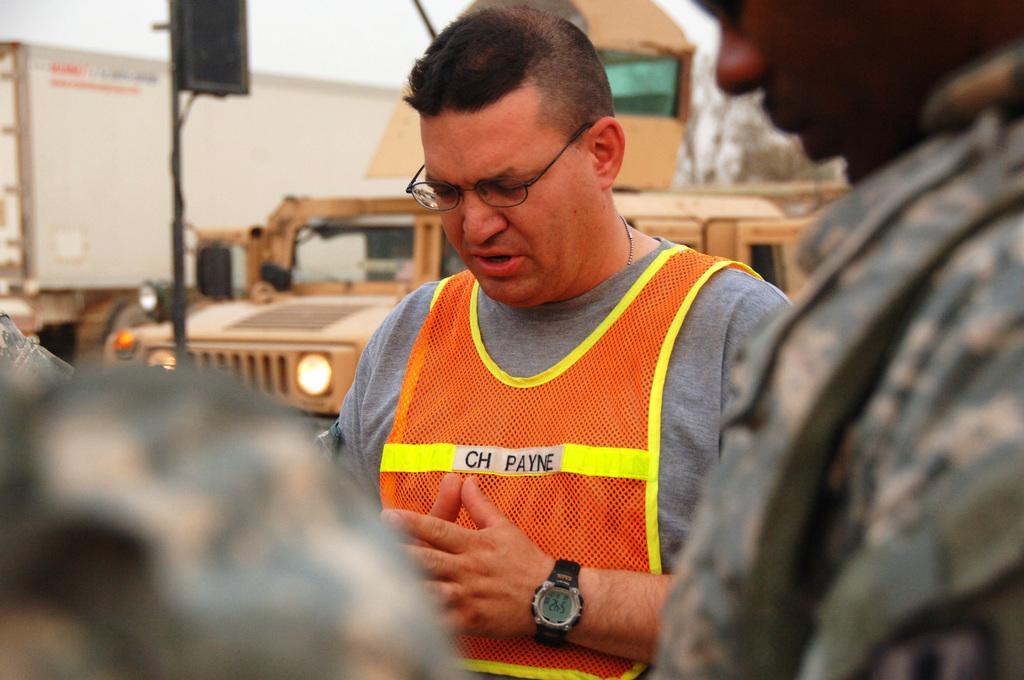Could you give a brief overview of what you see in this image? In this image I can see few people. In the background I can see the black color object to the pole, many vehicles, trees and the sky. 